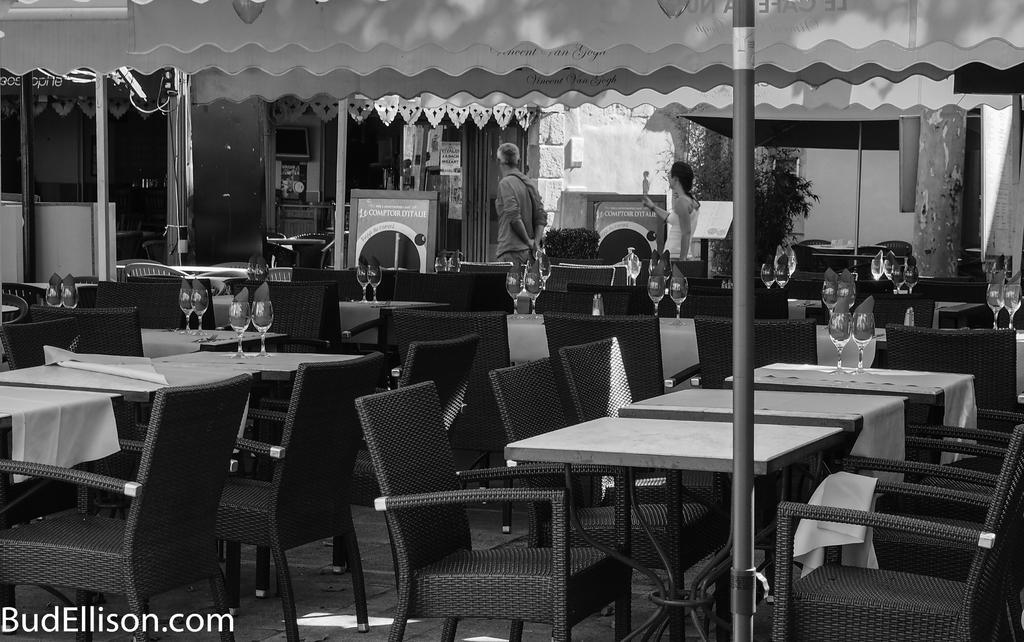What type of furniture is arranged in the image? There are tables with chairs arranged in the image. Can you describe any activity taking place in the image? Two persons are walking in the image. Where are the two persons located in the image? The two persons are in the top center of the image. How many cars can be seen in the image? There are no cars present in the image. What type of bird is perched on the bucket in the image? There is no bucket or bird present in the image. 